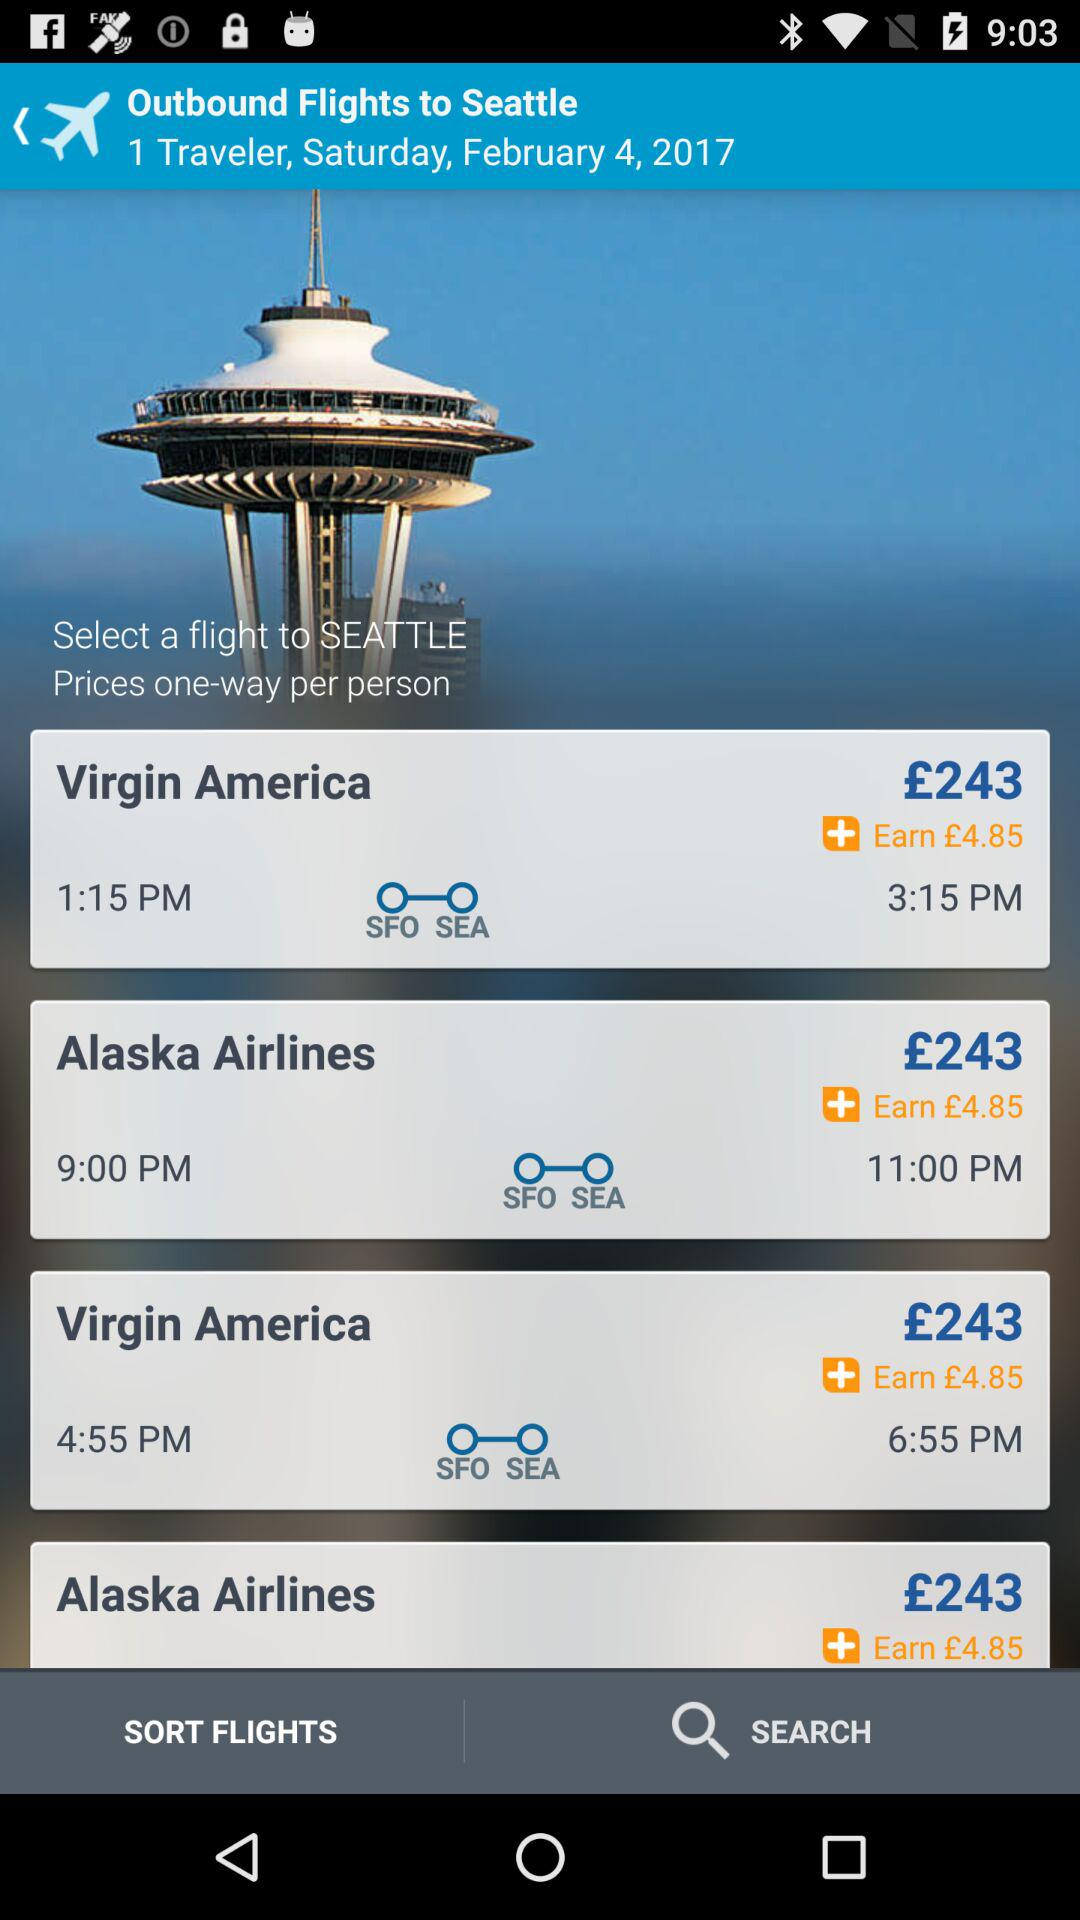How many travelers are there? There is 1 traveler. 